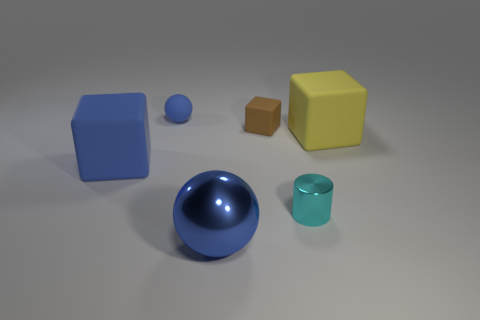Subtract all large yellow cubes. How many cubes are left? 2 Subtract 2 balls. How many balls are left? 0 Add 2 gray spheres. How many objects exist? 8 Subtract all blue blocks. How many blocks are left? 2 Subtract all cylinders. How many objects are left? 5 Add 4 tiny blue matte spheres. How many tiny blue matte spheres are left? 5 Add 6 big blue metallic cubes. How many big blue metallic cubes exist? 6 Subtract 0 cyan spheres. How many objects are left? 6 Subtract all red cylinders. Subtract all yellow blocks. How many cylinders are left? 1 Subtract all tiny purple matte cylinders. Subtract all yellow rubber objects. How many objects are left? 5 